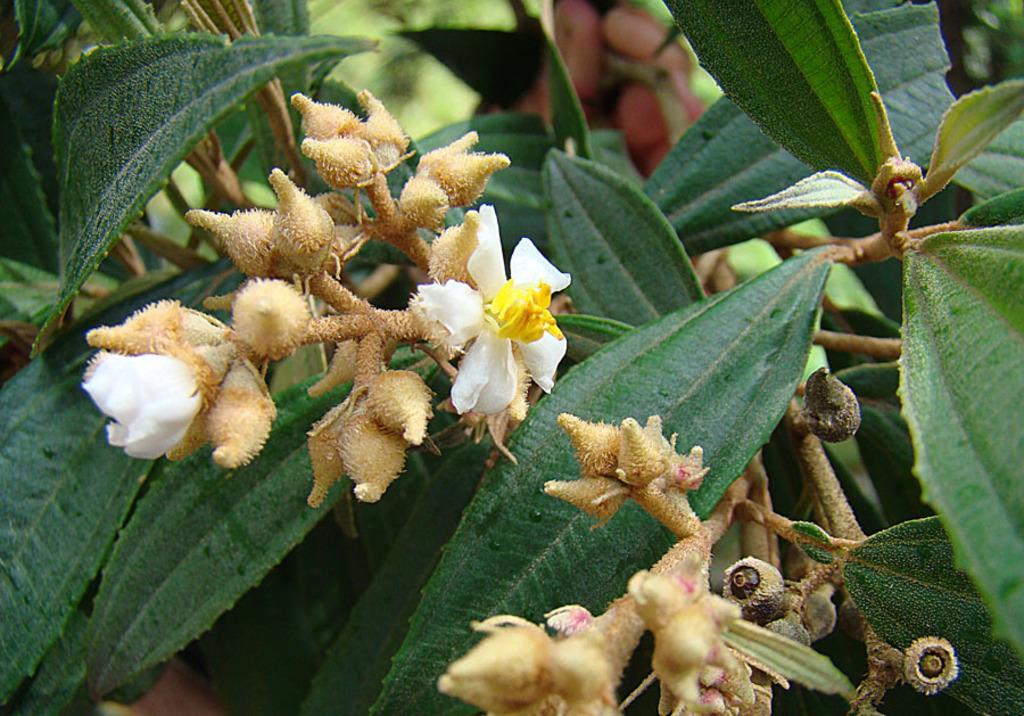How would you summarize this image in a sentence or two? In this picture I can see that there are some flowers and there are some plants. 